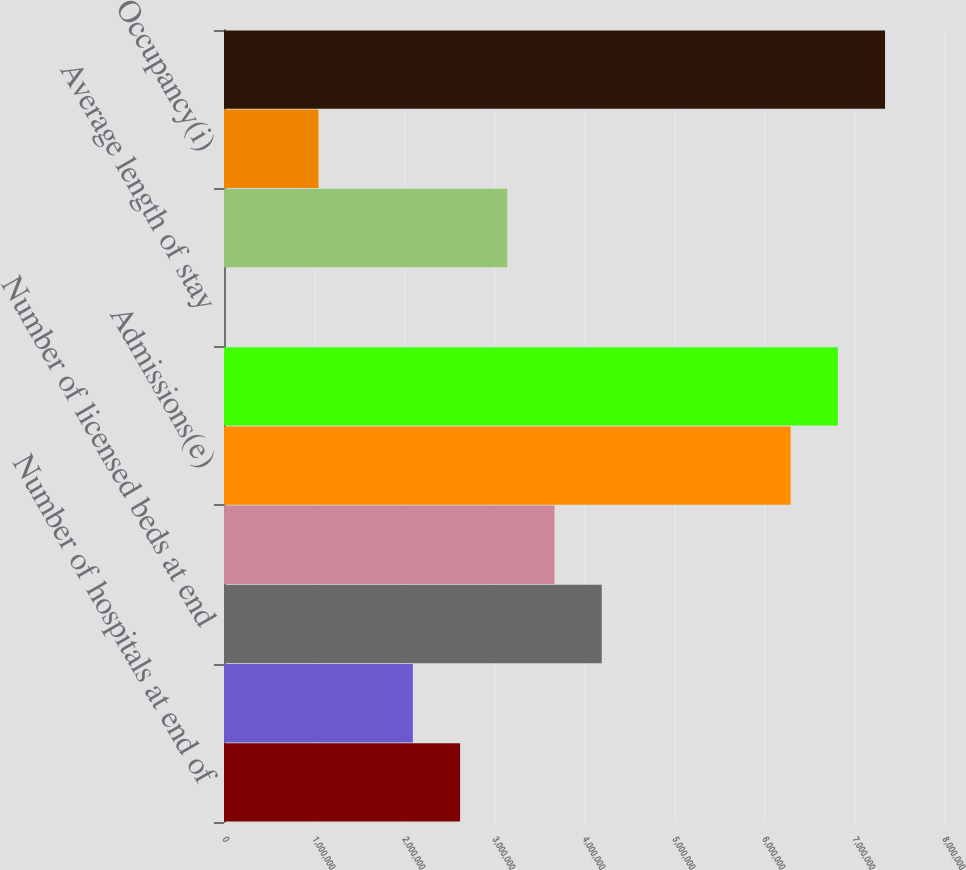Convert chart to OTSL. <chart><loc_0><loc_0><loc_500><loc_500><bar_chart><fcel>Number of hospitals at end of<fcel>Number of freestanding<fcel>Number of licensed beds at end<fcel>Weighted average licensed<fcel>Admissions(e)<fcel>Equivalent admissions(f)<fcel>Average length of stay<fcel>Average daily census(h)<fcel>Occupancy(i)<fcel>Emergency room visits(j)<nl><fcel>2.6232e+06<fcel>2.09856e+06<fcel>4.19712e+06<fcel>3.67248e+06<fcel>6.29568e+06<fcel>6.82032e+06<fcel>4.9<fcel>3.14784e+06<fcel>1.04928e+06<fcel>7.34496e+06<nl></chart> 